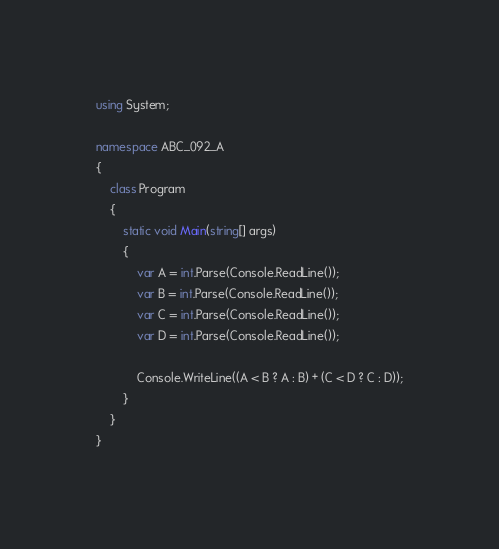<code> <loc_0><loc_0><loc_500><loc_500><_C#_>using System;

namespace ABC_092_A
{
    class Program
    {
        static void Main(string[] args)
        {
            var A = int.Parse(Console.ReadLine());
            var B = int.Parse(Console.ReadLine());
            var C = int.Parse(Console.ReadLine());
            var D = int.Parse(Console.ReadLine());

            Console.WriteLine((A < B ? A : B) + (C < D ? C : D));
        }
    }
}
</code> 